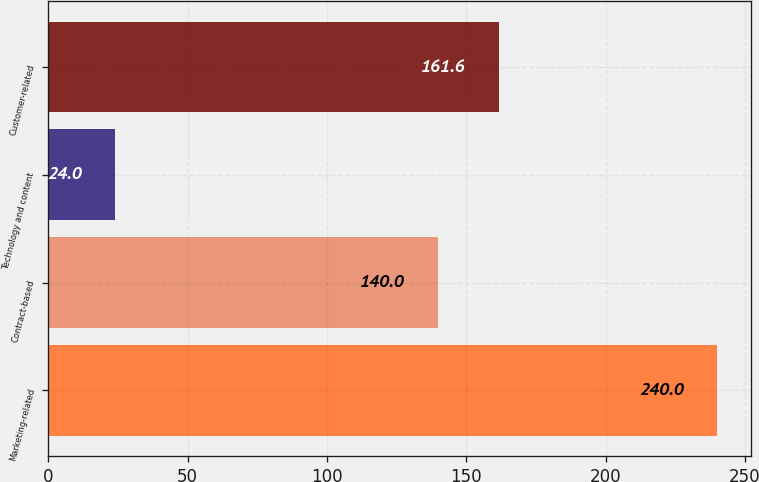<chart> <loc_0><loc_0><loc_500><loc_500><bar_chart><fcel>Marketing-related<fcel>Contract-based<fcel>Technology and content<fcel>Customer-related<nl><fcel>240<fcel>140<fcel>24<fcel>161.6<nl></chart> 